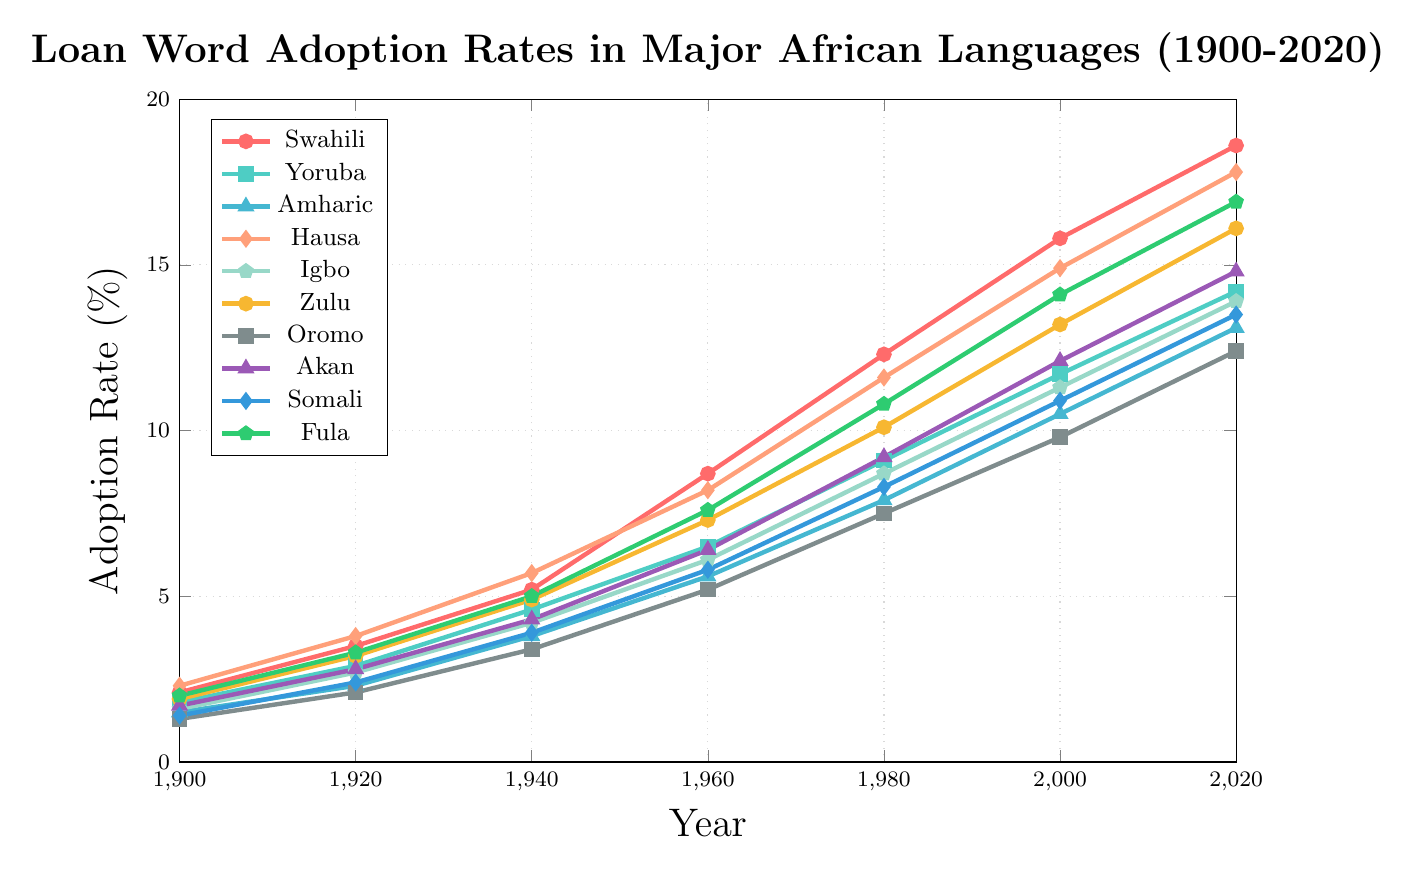Which language had the highest loan word adoption rate in 2020? First, locate the year 2020 on the x-axis, then identify the highest point among all data series. Swahili has the highest point at 18.6% in 2020.
Answer: Swahili What is the total loan word adoption rate for Yoruba from 1900 to 2020? Identify and sum all the Yoruba data points: 1.8 + 2.9 + 4.6 + 6.5 + 9.1 + 11.7 + 14.2. The total is 50.8%.
Answer: 50.8% Which two languages have the closest adoption rates in 1960? Identify the data points for all languages in 1960. The closest adoption rates are between Somali (5.8%) and Amharic (5.6%), which have a difference of 0.2%.
Answer: Somali and Amharic Has Fula consistently increased its loan word adoption rate over the years shown in the plot? Check the data points for Fula for each year: 1900, 1920, 1940, 1960, 1980, 2000, 2020. They are 2.0, 3.3, 5.0, 7.6, 10.8, 14.1, 16.9, which show a consistent increase.
Answer: Yes What is the rate of change in loan word adoption for Zulu from 1980 to 2000? Subtract the 1980 value from the 2000 value for Zulu: 13.2 - 10.1 = 3.1. This gives a rate of change of 3.1%.
Answer: 3.1% Which language had the lowest adoption rate in 1900? Identify the lowest data point from all languages in 1900. Oromo has the lowest adoption rate at 1.3% in 1900.
Answer: Oromo From 2000 to 2020, which language shows the second largest increase in adoption rate? Calculate the increase for each language from 2000 to 2020: Swahili (18.6-15.8=2.8), Yoruba (14.2-11.7=2.5), Amharic (13.1-10.5=2.6), Hausa (17.8-14.9=2.9), Igbo (13.9-11.3=2.6), Zulu (16.1-13.2=2.9), Oromo (12.4-9.8=2.6), Akan (14.8-12.1=2.7), Somali (13.5-10.9=2.6), Fula (16.9-14.1=2.8). The second largest increase is for Fula, Swahili, and Akan with 2.8%.
Answer: Fula, Swahili, Akan Which language's adoption rate surpassed 10% first, before any other language? Identify the first year each language surpassed 10%. Swahili reached 10.1% in 1980, which is earlier than any other language.
Answer: Swahili What is the average adoption rate for Akan over the entire period? Sum the data points for Akan (1.7 + 2.8 + 4.3 + 6.4 + 9.2 + 12.1 + 14.8) and then divide by the number of years (7). The total is 51.3; divided by 7 is approximately 7.33%.
Answer: 7.33% Which language showed the greatest overall increase from 1900 to 2020? Calculate the overall increase for each language from 1900 to 2020: Swahili (18.6-2.1=16.5), Yoruba (14.2-1.8=12.4), Amharic (13.1-1.5=11.6), Hausa (17.8-2.3=15.5), Igbo (13.9-1.6=12.3), Zulu (16.1-1.9=14.2), Oromo (12.4-1.3=11.1), Akan (14.8-1.7=13.1), Somali (13.5-1.4=12.1), Fula (16.9-2.0=14.9). Swahili has the greatest increase at 16.5%.
Answer: Swahili 